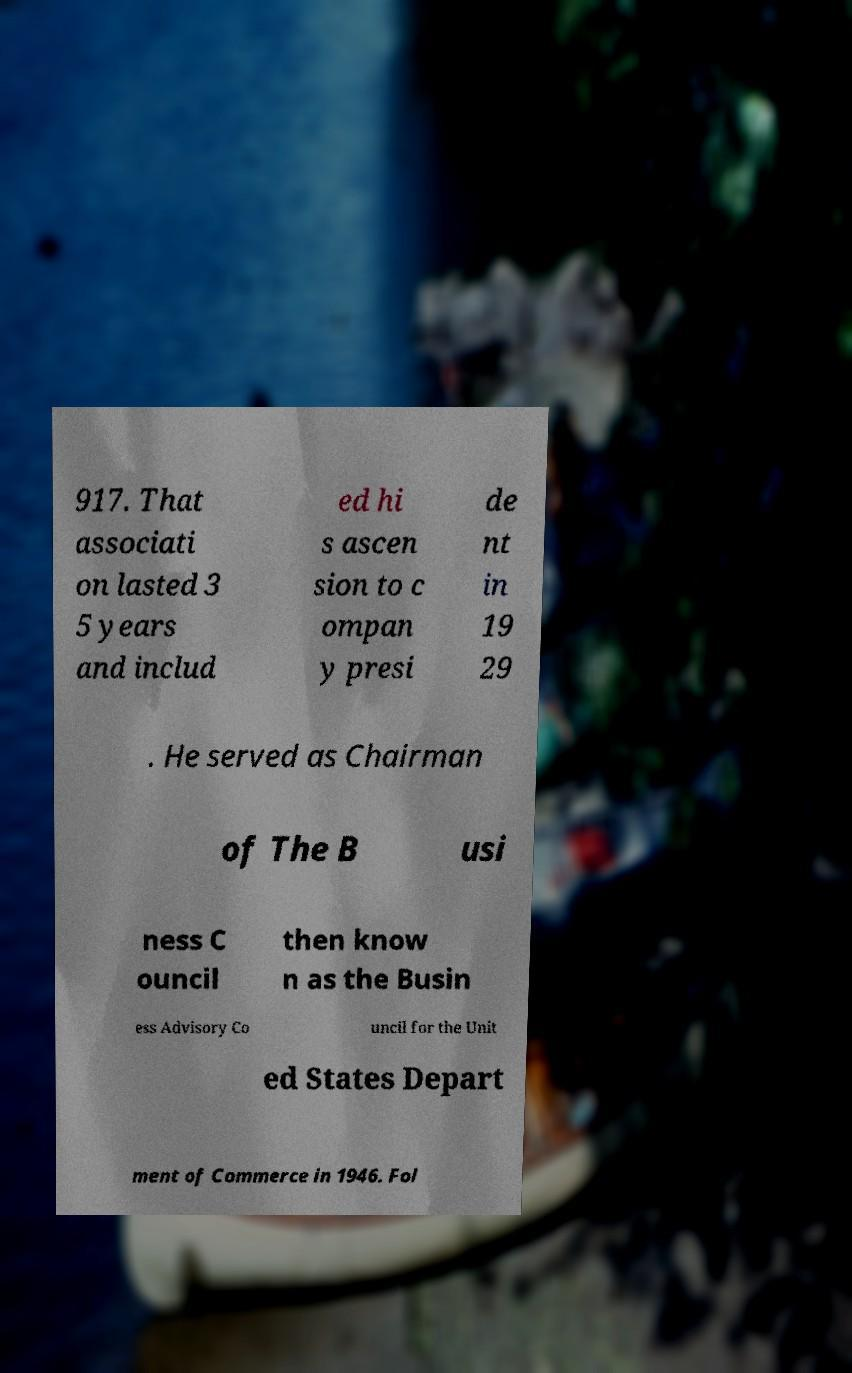Can you read and provide the text displayed in the image?This photo seems to have some interesting text. Can you extract and type it out for me? 917. That associati on lasted 3 5 years and includ ed hi s ascen sion to c ompan y presi de nt in 19 29 . He served as Chairman of The B usi ness C ouncil then know n as the Busin ess Advisory Co uncil for the Unit ed States Depart ment of Commerce in 1946. Fol 